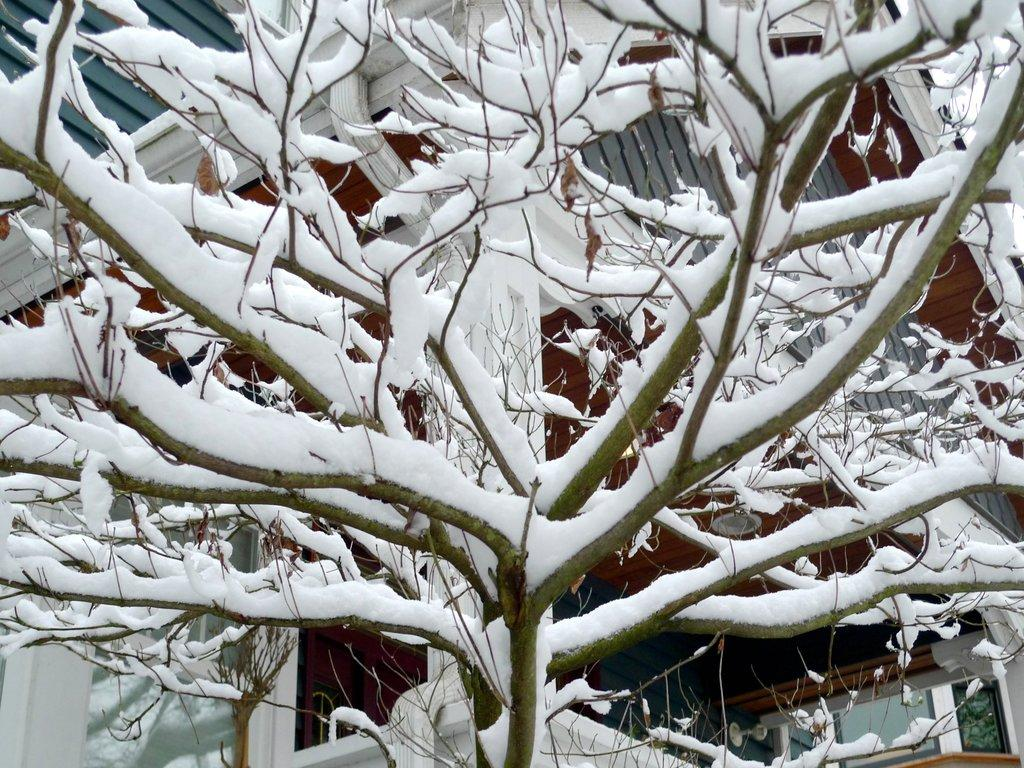What is the condition of the trees in the image? The trees in the image have dried branches and are covered in snow. What can be seen attached to a house in the image? There is an object attached to a house in the image. Can you describe the background of the image? There is a house in the background of the image. Where are the snakes hiding in the image? There are no snakes present in the image. What color is the crayon used to draw on the snow in the image? There is no crayon or drawing on the snow in the image. 